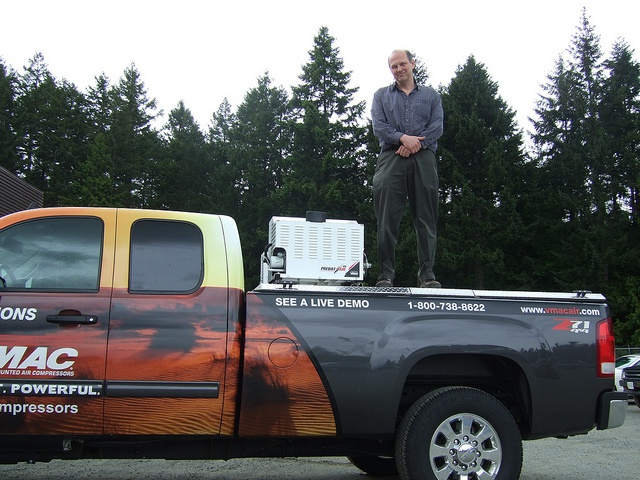Describe the objects in this image and their specific colors. I can see truck in white, black, gray, and maroon tones, people in white, black, gray, and darkblue tones, car in white, black, navy, gray, and darkgray tones, and car in white, black, lightblue, and darkgray tones in this image. 